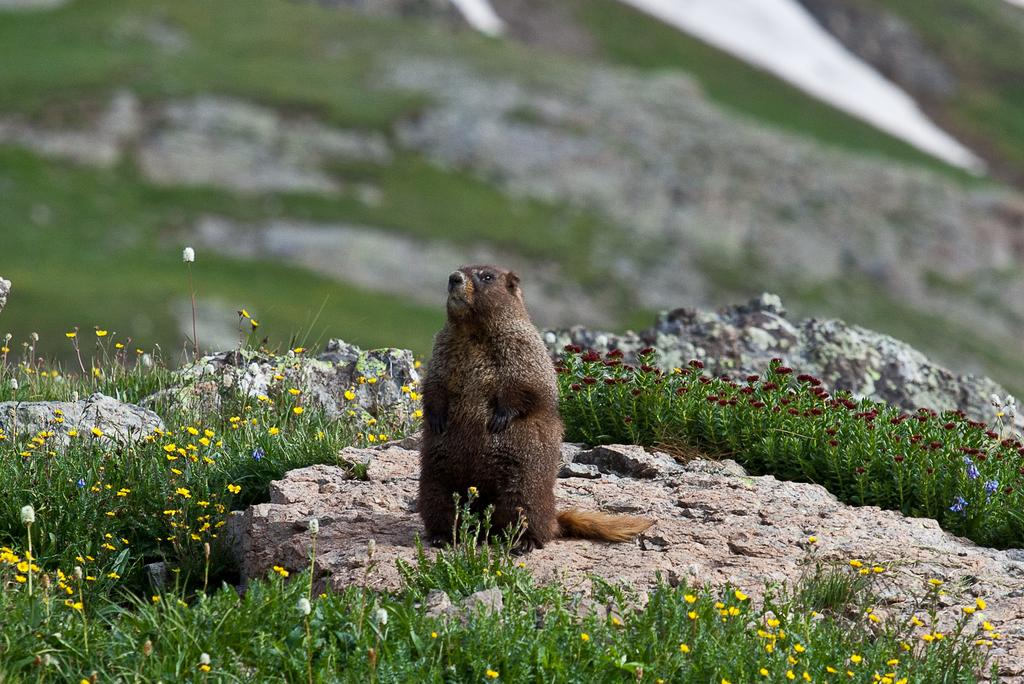What is the main subject in the center of the image? There is an animal in the center of the image. What type of natural features can be seen in the image? There are rocks and shrubs visible in the image. Are there any plants present in the image? Yes, flowers are visible in the image. Can you tell me how many geese are walking down the alley in the image? There is no alley or geese present in the image; it features an animal, rocks, shrubs, and flowers. 